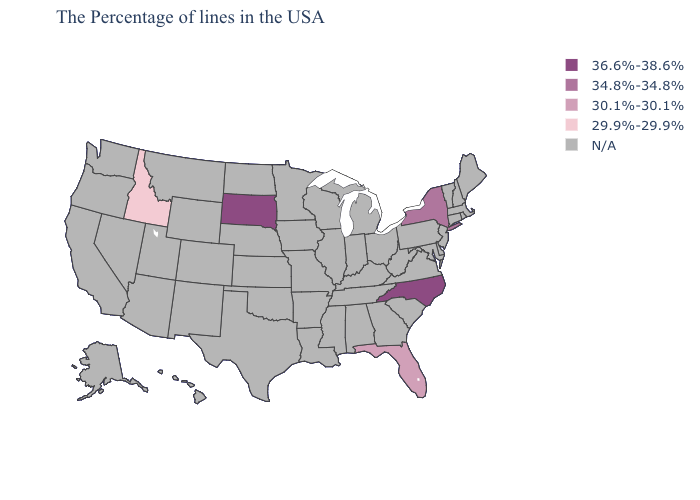Name the states that have a value in the range 30.1%-30.1%?
Quick response, please. Florida. What is the value of Nebraska?
Give a very brief answer. N/A. Which states have the lowest value in the USA?
Quick response, please. Idaho. What is the value of Rhode Island?
Answer briefly. N/A. Name the states that have a value in the range 29.9%-29.9%?
Answer briefly. Idaho. What is the value of Alabama?
Concise answer only. N/A. Which states have the lowest value in the USA?
Give a very brief answer. Idaho. What is the highest value in the USA?
Short answer required. 36.6%-38.6%. What is the highest value in the MidWest ?
Give a very brief answer. 36.6%-38.6%. Among the states that border New Jersey , which have the highest value?
Answer briefly. New York. Name the states that have a value in the range 36.6%-38.6%?
Keep it brief. North Carolina, South Dakota. Does Florida have the highest value in the USA?
Be succinct. No. Does Idaho have the lowest value in the USA?
Be succinct. Yes. 